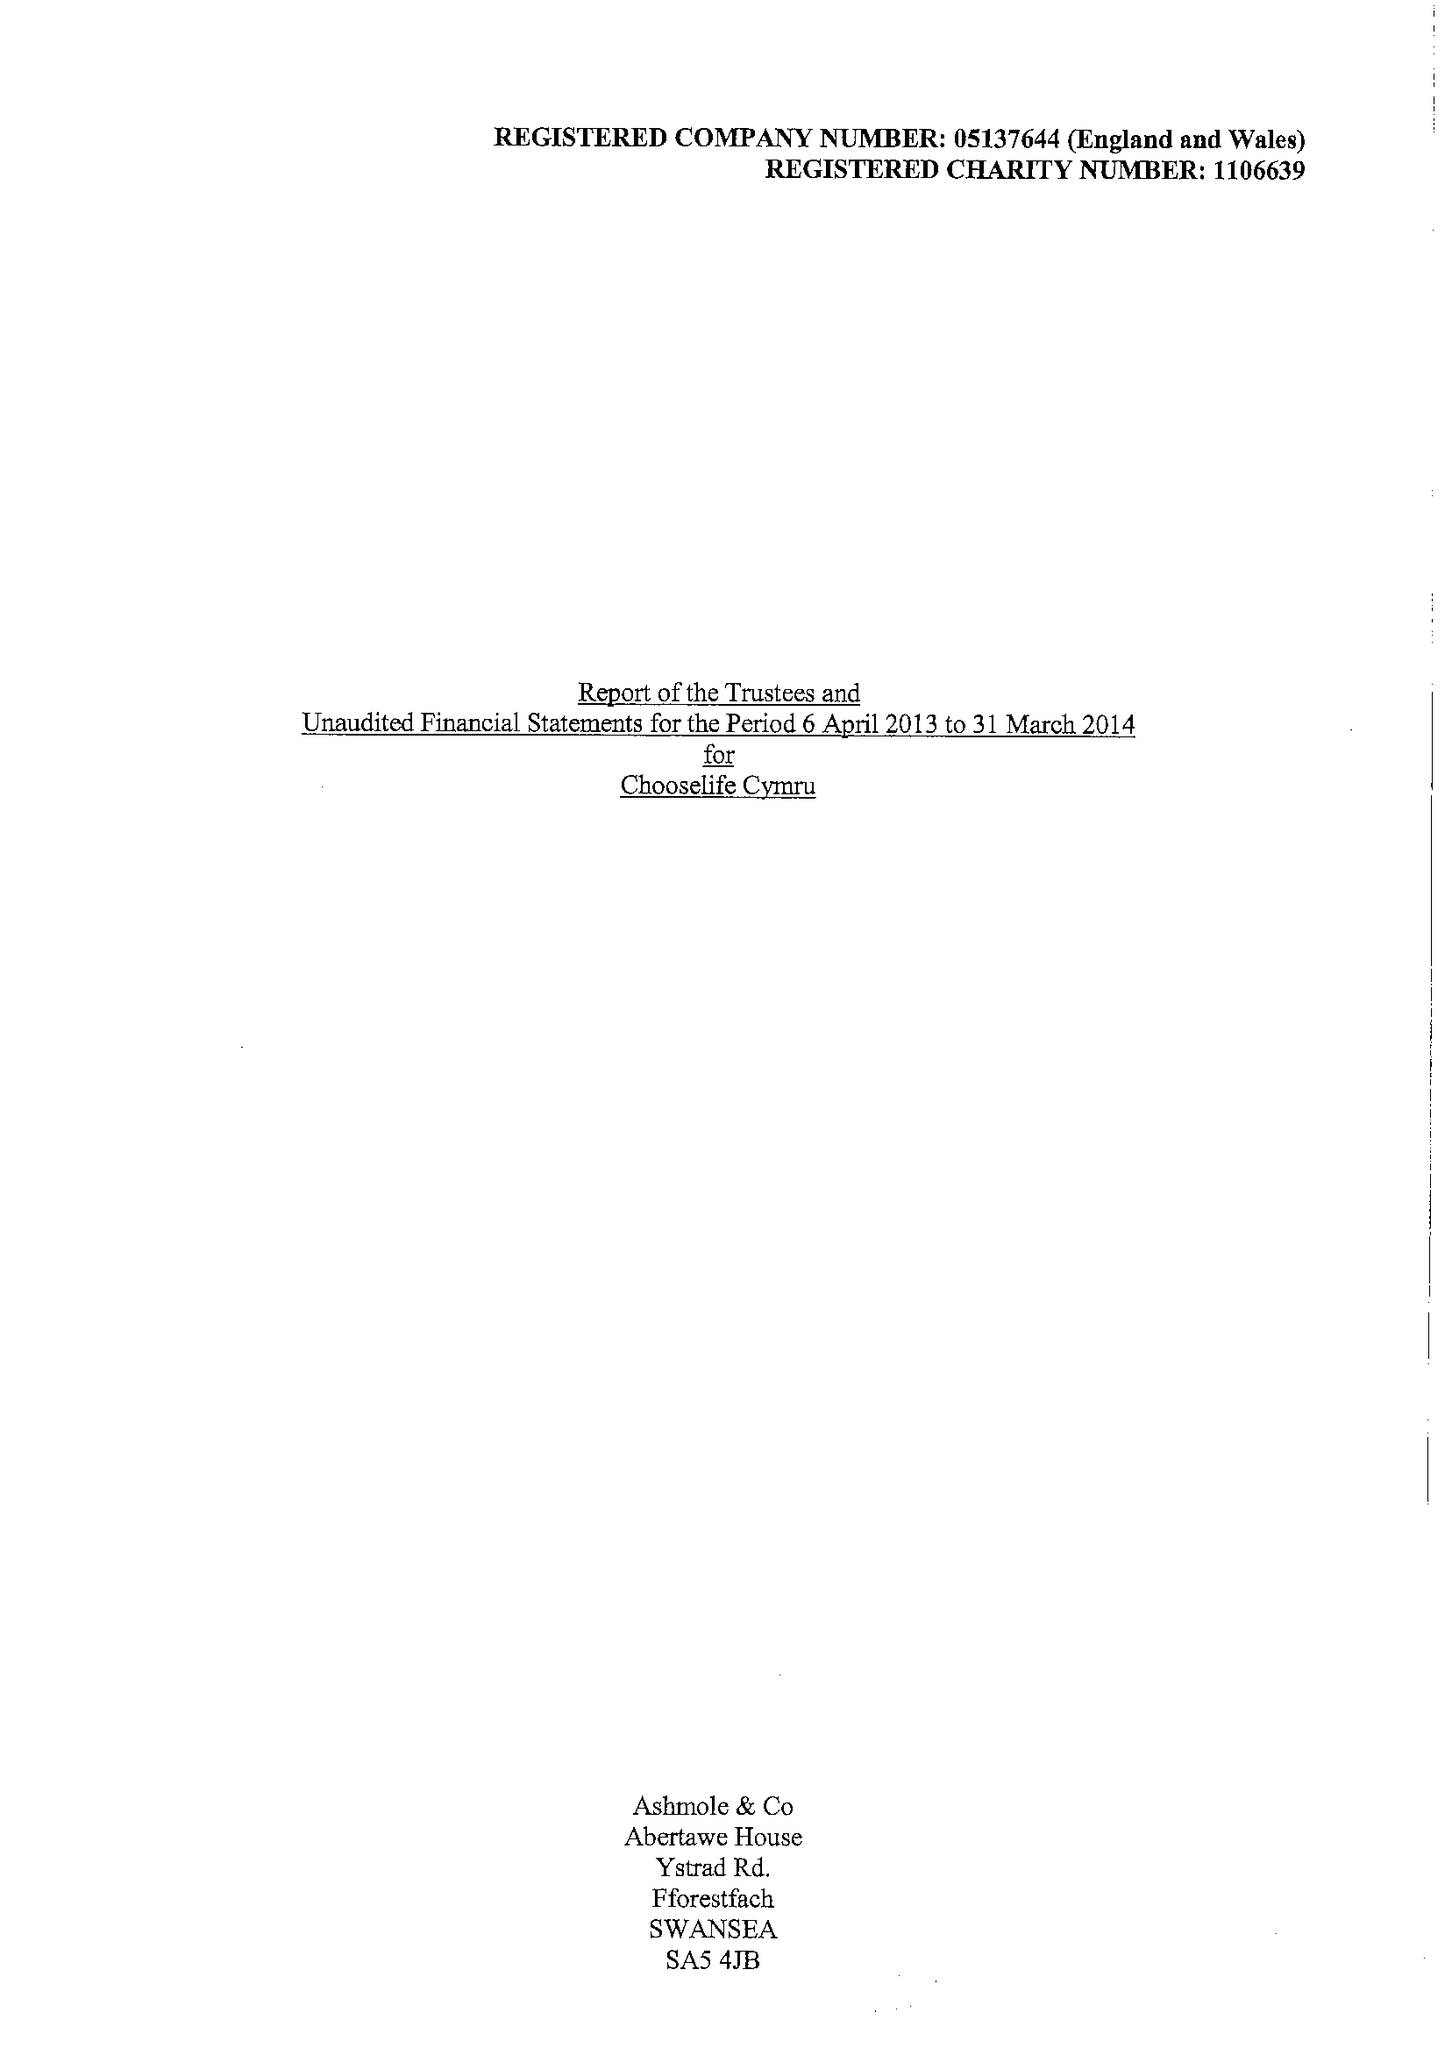What is the value for the income_annually_in_british_pounds?
Answer the question using a single word or phrase. 342883.00 